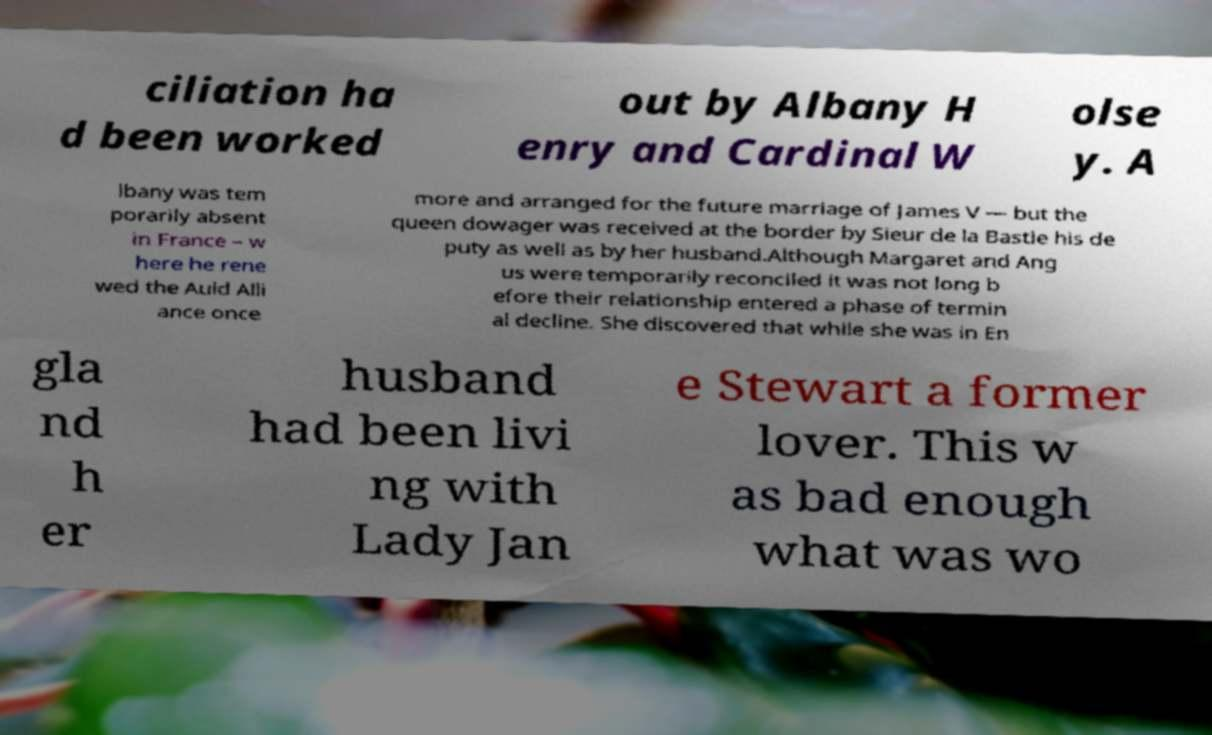Could you assist in decoding the text presented in this image and type it out clearly? ciliation ha d been worked out by Albany H enry and Cardinal W olse y. A lbany was tem porarily absent in France – w here he rene wed the Auld Alli ance once more and arranged for the future marriage of James V — but the queen dowager was received at the border by Sieur de la Bastie his de puty as well as by her husband.Although Margaret and Ang us were temporarily reconciled it was not long b efore their relationship entered a phase of termin al decline. She discovered that while she was in En gla nd h er husband had been livi ng with Lady Jan e Stewart a former lover. This w as bad enough what was wo 